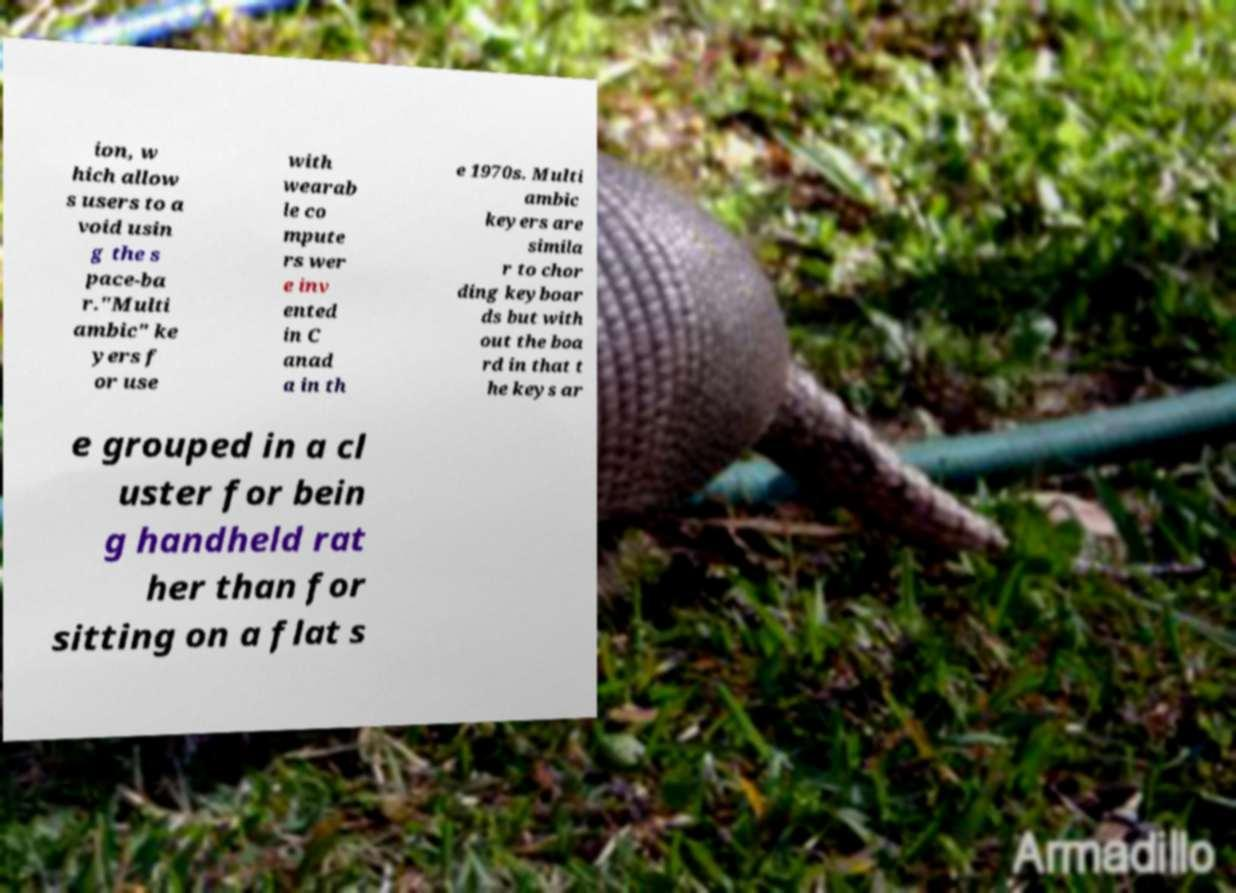Can you read and provide the text displayed in the image?This photo seems to have some interesting text. Can you extract and type it out for me? ion, w hich allow s users to a void usin g the s pace-ba r."Multi ambic" ke yers f or use with wearab le co mpute rs wer e inv ented in C anad a in th e 1970s. Multi ambic keyers are simila r to chor ding keyboar ds but with out the boa rd in that t he keys ar e grouped in a cl uster for bein g handheld rat her than for sitting on a flat s 